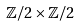Convert formula to latex. <formula><loc_0><loc_0><loc_500><loc_500>\mathbb { Z } / 2 \times \mathbb { Z } / 2</formula> 